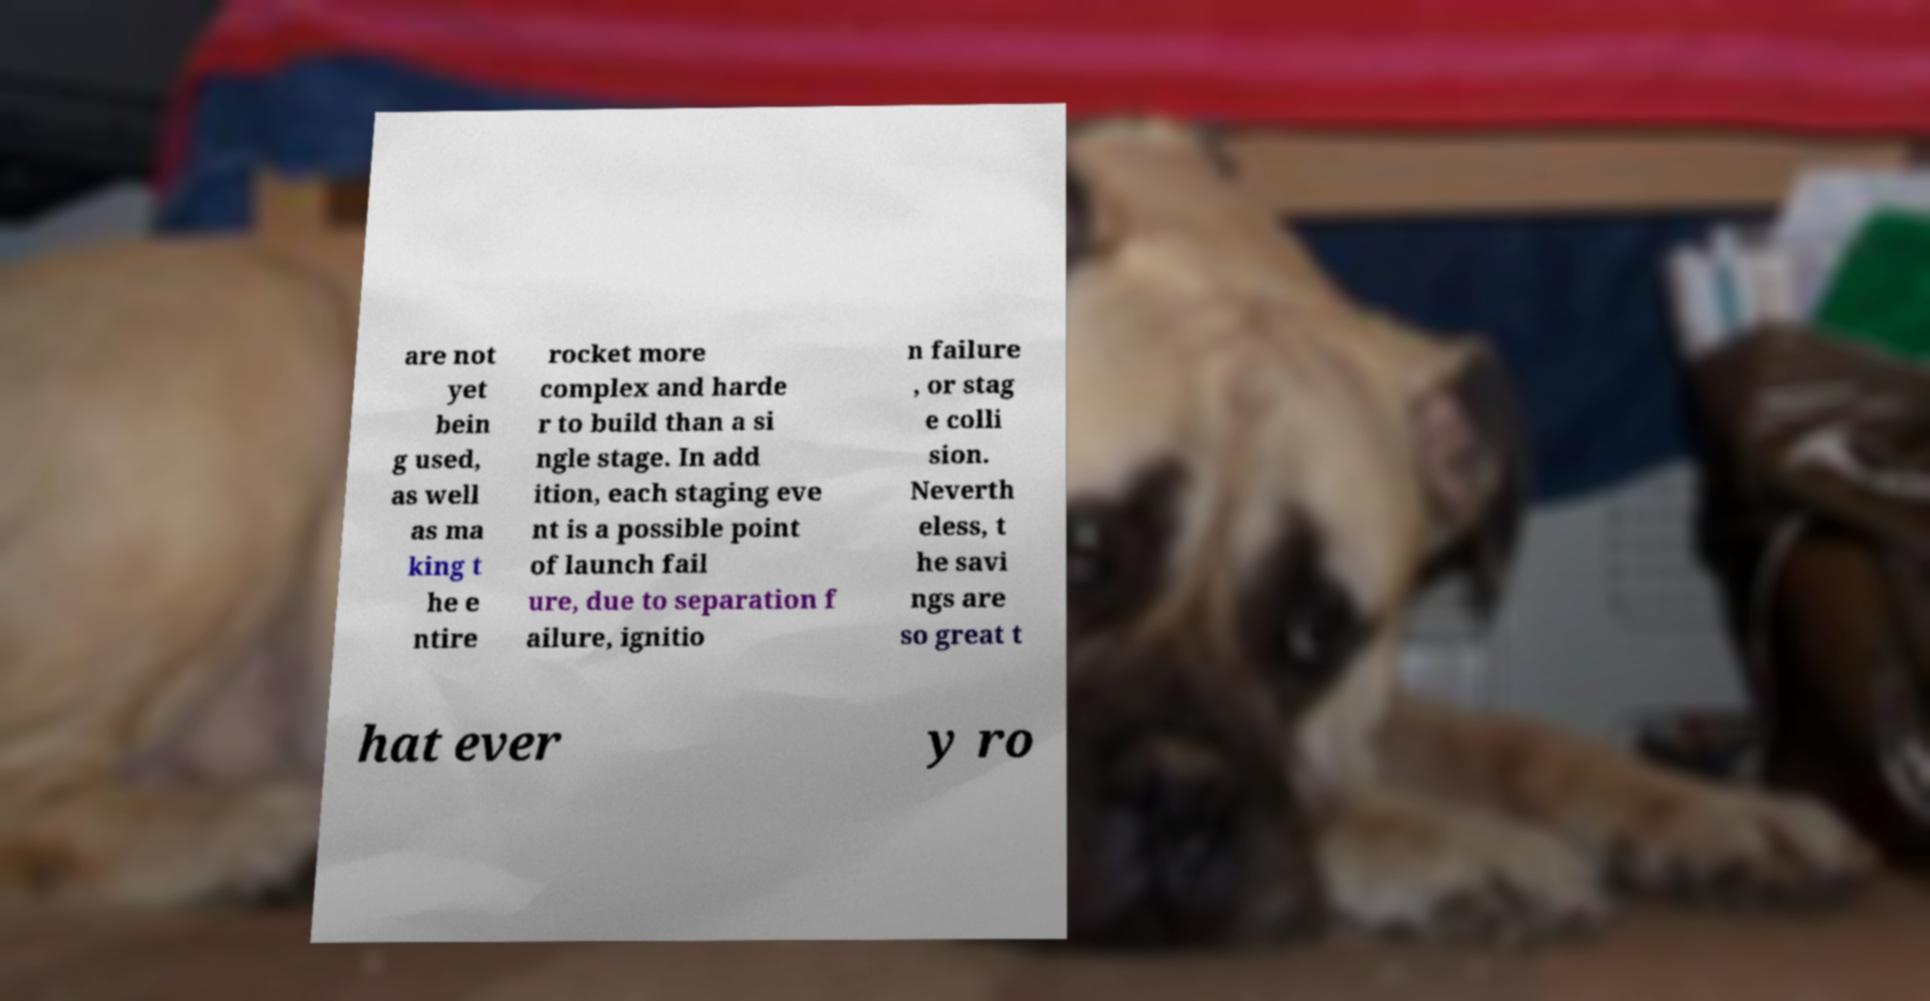For documentation purposes, I need the text within this image transcribed. Could you provide that? are not yet bein g used, as well as ma king t he e ntire rocket more complex and harde r to build than a si ngle stage. In add ition, each staging eve nt is a possible point of launch fail ure, due to separation f ailure, ignitio n failure , or stag e colli sion. Neverth eless, t he savi ngs are so great t hat ever y ro 